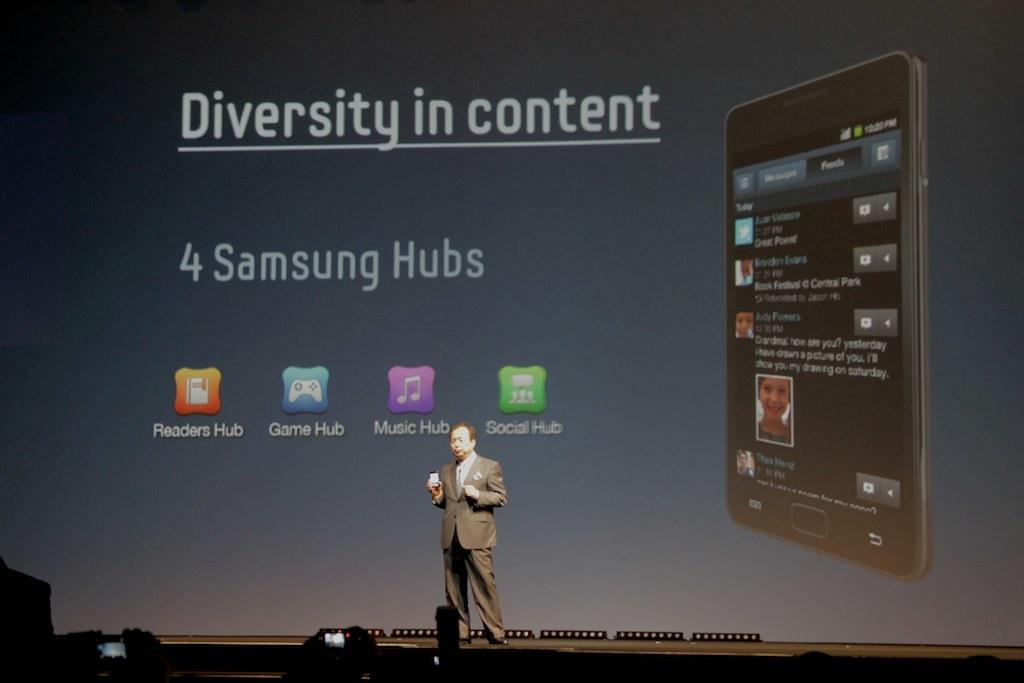<image>
Describe the image concisely. Someone is speaking on stage with a presentation about 4 Samsung Hubs. 